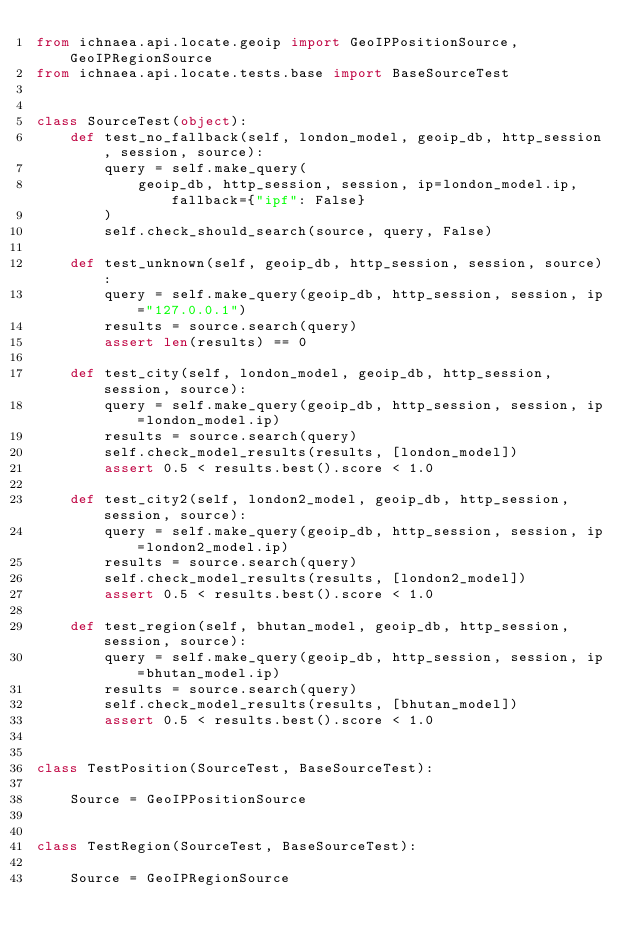<code> <loc_0><loc_0><loc_500><loc_500><_Python_>from ichnaea.api.locate.geoip import GeoIPPositionSource, GeoIPRegionSource
from ichnaea.api.locate.tests.base import BaseSourceTest


class SourceTest(object):
    def test_no_fallback(self, london_model, geoip_db, http_session, session, source):
        query = self.make_query(
            geoip_db, http_session, session, ip=london_model.ip, fallback={"ipf": False}
        )
        self.check_should_search(source, query, False)

    def test_unknown(self, geoip_db, http_session, session, source):
        query = self.make_query(geoip_db, http_session, session, ip="127.0.0.1")
        results = source.search(query)
        assert len(results) == 0

    def test_city(self, london_model, geoip_db, http_session, session, source):
        query = self.make_query(geoip_db, http_session, session, ip=london_model.ip)
        results = source.search(query)
        self.check_model_results(results, [london_model])
        assert 0.5 < results.best().score < 1.0

    def test_city2(self, london2_model, geoip_db, http_session, session, source):
        query = self.make_query(geoip_db, http_session, session, ip=london2_model.ip)
        results = source.search(query)
        self.check_model_results(results, [london2_model])
        assert 0.5 < results.best().score < 1.0

    def test_region(self, bhutan_model, geoip_db, http_session, session, source):
        query = self.make_query(geoip_db, http_session, session, ip=bhutan_model.ip)
        results = source.search(query)
        self.check_model_results(results, [bhutan_model])
        assert 0.5 < results.best().score < 1.0


class TestPosition(SourceTest, BaseSourceTest):

    Source = GeoIPPositionSource


class TestRegion(SourceTest, BaseSourceTest):

    Source = GeoIPRegionSource
</code> 